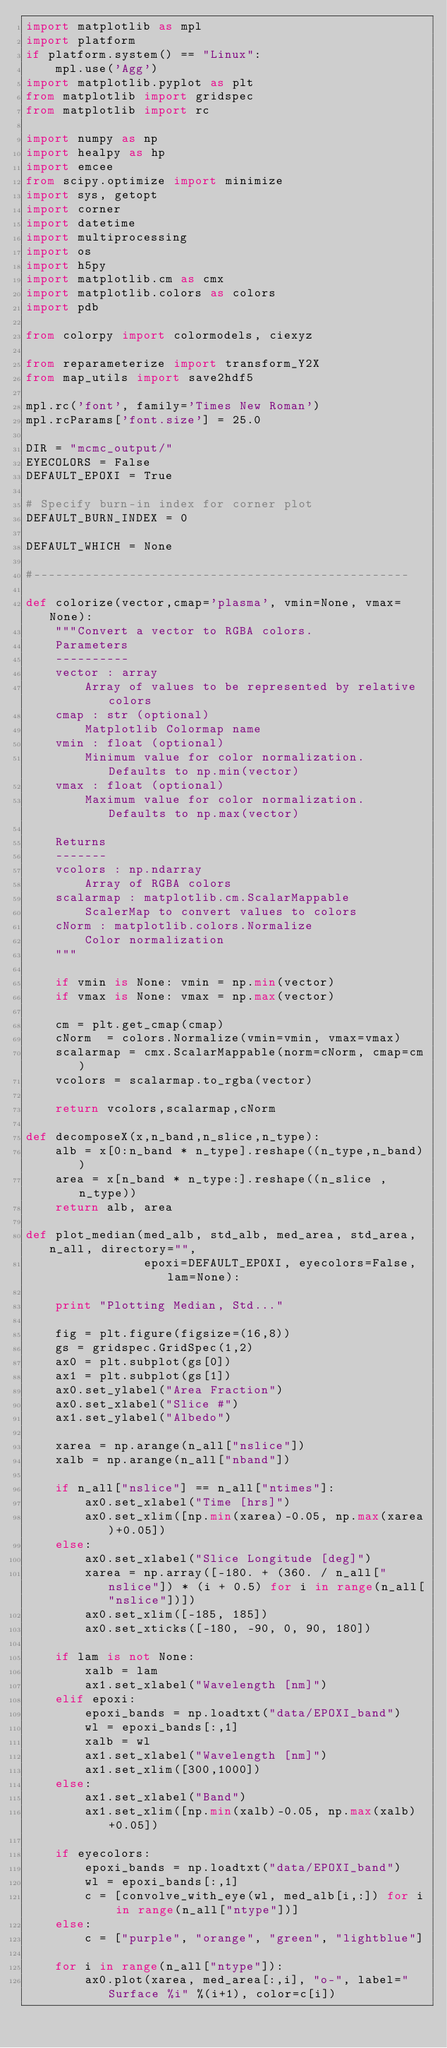<code> <loc_0><loc_0><loc_500><loc_500><_Python_>import matplotlib as mpl
import platform
if platform.system() == "Linux":
    mpl.use('Agg')
import matplotlib.pyplot as plt
from matplotlib import gridspec
from matplotlib import rc

import numpy as np
import healpy as hp
import emcee
from scipy.optimize import minimize
import sys, getopt
import corner
import datetime
import multiprocessing
import os
import h5py
import matplotlib.cm as cmx
import matplotlib.colors as colors
import pdb

from colorpy import colormodels, ciexyz

from reparameterize import transform_Y2X
from map_utils import save2hdf5

mpl.rc('font', family='Times New Roman')
mpl.rcParams['font.size'] = 25.0

DIR = "mcmc_output/"
EYECOLORS = False
DEFAULT_EPOXI = True

# Specify burn-in index for corner plot
DEFAULT_BURN_INDEX = 0

DEFAULT_WHICH = None

#---------------------------------------------------

def colorize(vector,cmap='plasma', vmin=None, vmax=None):
    """Convert a vector to RGBA colors.
    Parameters
    ----------
    vector : array
        Array of values to be represented by relative colors
    cmap : str (optional)
        Matplotlib Colormap name
    vmin : float (optional)
        Minimum value for color normalization. Defaults to np.min(vector)
    vmax : float (optional)
        Maximum value for color normalization. Defaults to np.max(vector)

    Returns
    -------
    vcolors : np.ndarray
        Array of RGBA colors
    scalarmap : matplotlib.cm.ScalarMappable
        ScalerMap to convert values to colors
    cNorm : matplotlib.colors.Normalize
        Color normalization
    """

    if vmin is None: vmin = np.min(vector)
    if vmax is None: vmax = np.max(vector)

    cm = plt.get_cmap(cmap)
    cNorm  = colors.Normalize(vmin=vmin, vmax=vmax)
    scalarmap = cmx.ScalarMappable(norm=cNorm, cmap=cm)
    vcolors = scalarmap.to_rgba(vector)

    return vcolors,scalarmap,cNorm

def decomposeX(x,n_band,n_slice,n_type):
    alb = x[0:n_band * n_type].reshape((n_type,n_band))
    area = x[n_band * n_type:].reshape((n_slice , n_type))
    return alb, area

def plot_median(med_alb, std_alb, med_area, std_area, n_all, directory="",
                epoxi=DEFAULT_EPOXI, eyecolors=False, lam=None):

    print "Plotting Median, Std..."

    fig = plt.figure(figsize=(16,8))
    gs = gridspec.GridSpec(1,2)
    ax0 = plt.subplot(gs[0])
    ax1 = plt.subplot(gs[1])
    ax0.set_ylabel("Area Fraction")
    ax0.set_xlabel("Slice #")
    ax1.set_ylabel("Albedo")

    xarea = np.arange(n_all["nslice"])
    xalb = np.arange(n_all["nband"])

    if n_all["nslice"] == n_all["ntimes"]:
        ax0.set_xlabel("Time [hrs]")
        ax0.set_xlim([np.min(xarea)-0.05, np.max(xarea)+0.05])
    else:
        ax0.set_xlabel("Slice Longitude [deg]")
        xarea = np.array([-180. + (360. / n_all["nslice"]) * (i + 0.5) for i in range(n_all["nslice"])])
        ax0.set_xlim([-185, 185])
        ax0.set_xticks([-180, -90, 0, 90, 180])

    if lam is not None:
        xalb = lam
        ax1.set_xlabel("Wavelength [nm]")
    elif epoxi:
        epoxi_bands = np.loadtxt("data/EPOXI_band")
        wl = epoxi_bands[:,1]
        xalb = wl
        ax1.set_xlabel("Wavelength [nm]")
        ax1.set_xlim([300,1000])
    else:
        ax1.set_xlabel("Band")
        ax1.set_xlim([np.min(xalb)-0.05, np.max(xalb)+0.05])

    if eyecolors:
        epoxi_bands = np.loadtxt("data/EPOXI_band")
        wl = epoxi_bands[:,1]
        c = [convolve_with_eye(wl, med_alb[i,:]) for i in range(n_all["ntype"])]
    else:
        c = ["purple", "orange", "green", "lightblue"]

    for i in range(n_all["ntype"]):
        ax0.plot(xarea, med_area[:,i], "o-", label="Surface %i" %(i+1), color=c[i])</code> 